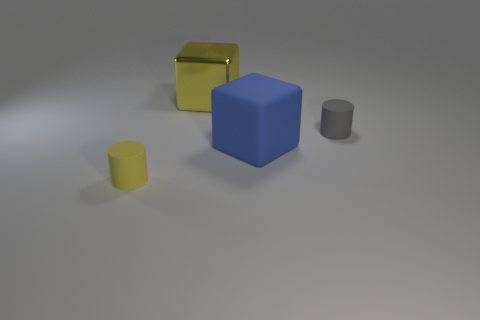What is the size of the thing that is behind the matte cylinder right of the large yellow object? The object behind the matte cylinder is a blue cube, which is medium in size when compared to the other objects in the image. Specifically, it's larger than the matte cylinder and the small yellow cylinder but smaller than the large yellow object, which appears to be a container with an open lid. 